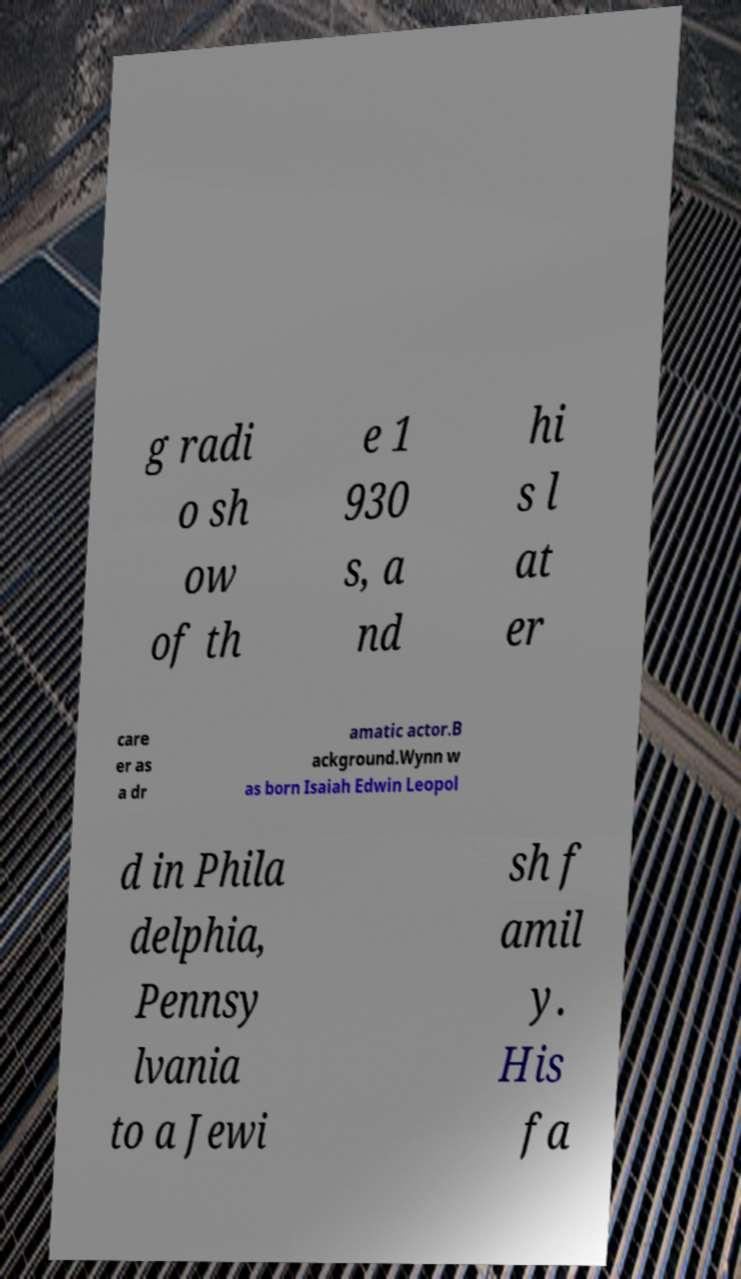Can you accurately transcribe the text from the provided image for me? g radi o sh ow of th e 1 930 s, a nd hi s l at er care er as a dr amatic actor.B ackground.Wynn w as born Isaiah Edwin Leopol d in Phila delphia, Pennsy lvania to a Jewi sh f amil y. His fa 